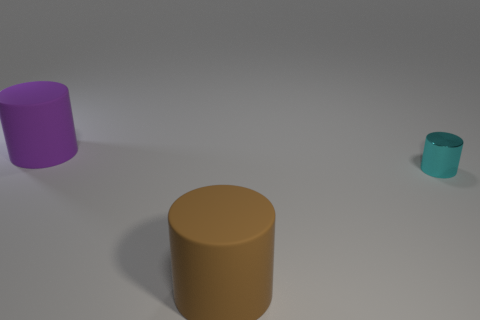Add 2 large rubber cylinders. How many objects exist? 5 Subtract all matte cylinders. How many cylinders are left? 1 Subtract all purple cylinders. How many cylinders are left? 2 Add 2 purple matte objects. How many purple matte objects are left? 3 Add 3 cyan shiny cylinders. How many cyan shiny cylinders exist? 4 Subtract 0 cyan blocks. How many objects are left? 3 Subtract 1 cylinders. How many cylinders are left? 2 Subtract all cyan cylinders. Subtract all blue blocks. How many cylinders are left? 2 Subtract all red blocks. How many yellow cylinders are left? 0 Subtract all tiny matte cylinders. Subtract all large brown matte things. How many objects are left? 2 